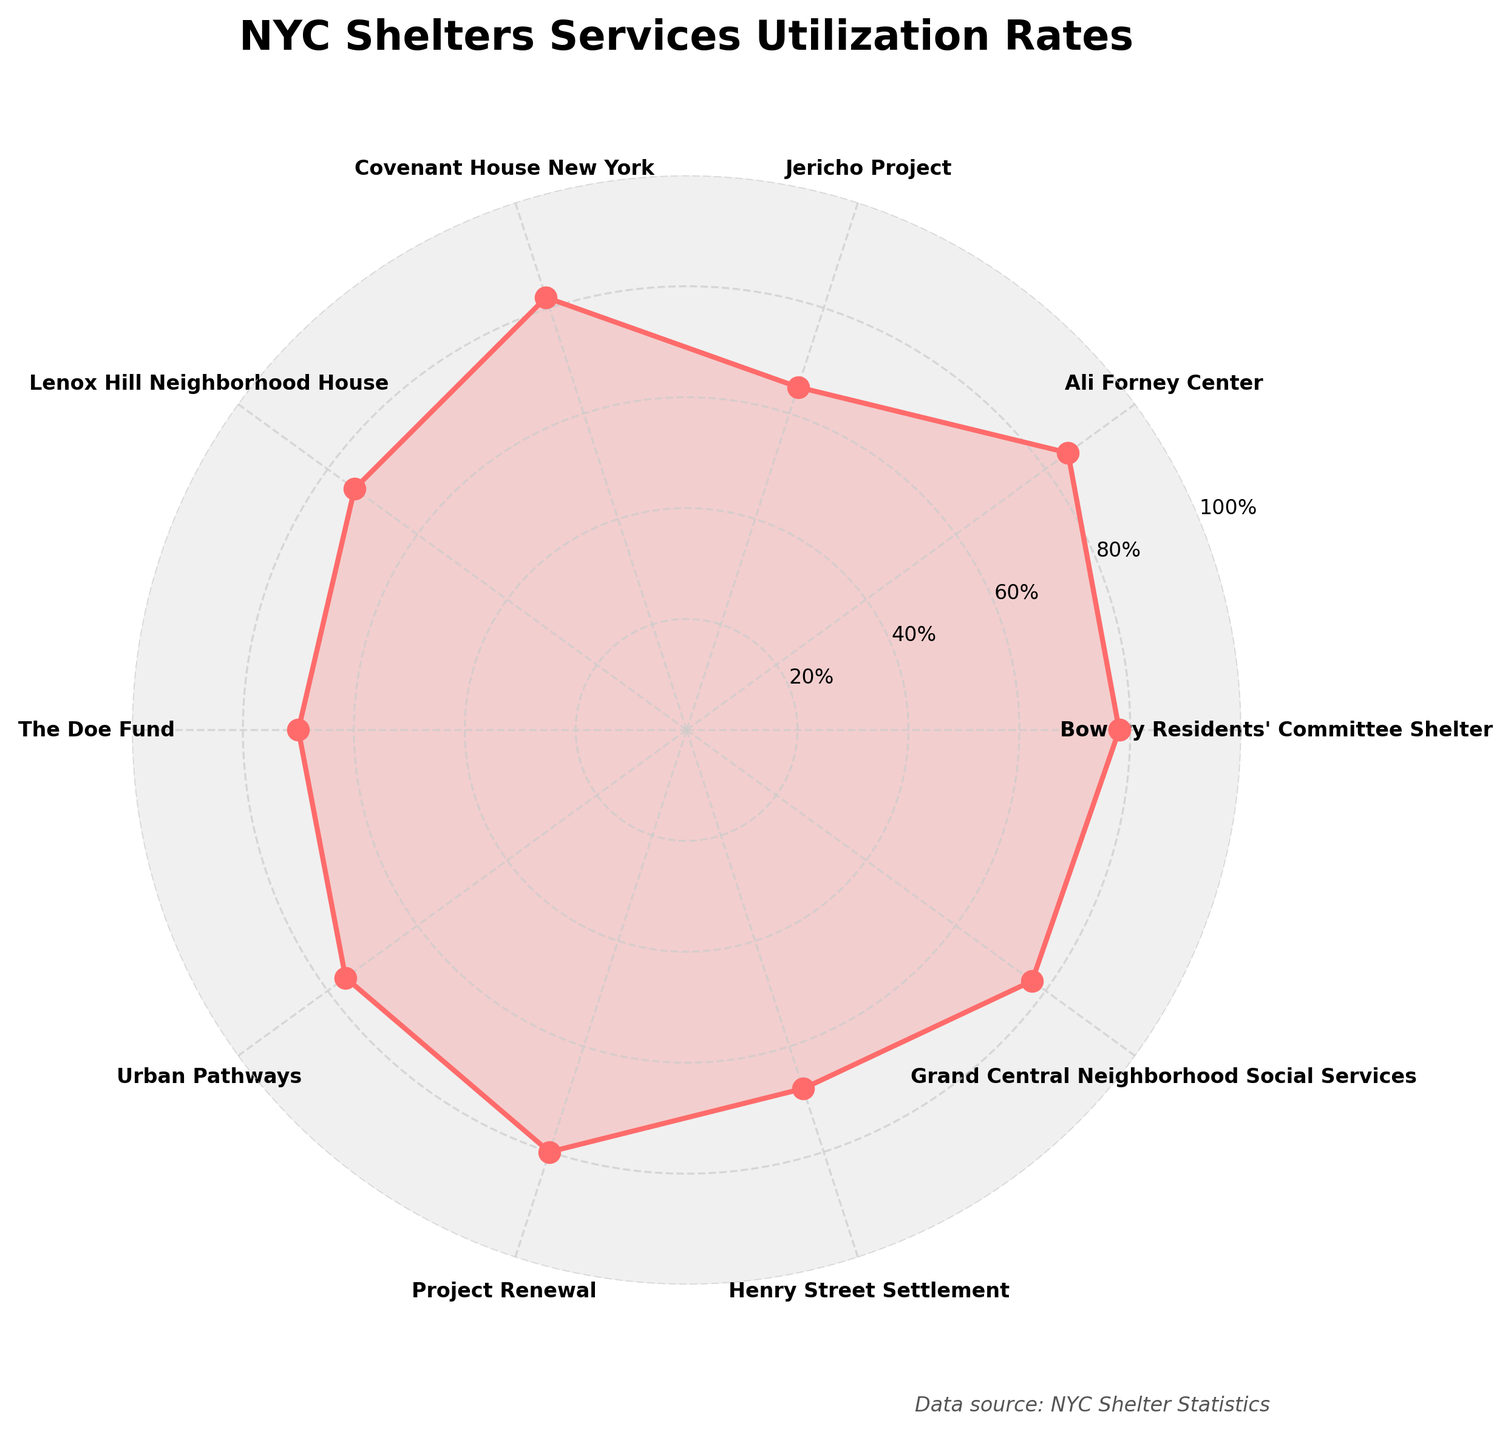What is the title of the chart? The title is displayed at the top of the chart and reads "NYC Shelters Services Utilization Rates".
Answer: NYC Shelters Services Utilization Rates How many shelters are represented in the chart? The number of shelters can be counted along the edges of the polar chart where the shelter names are listed.
Answer: 10 Which shelter has the highest services utilization rate? The highest utilization rate can be identified by locating the peak point furthest from the center of the chart. This corresponds to the Ali Forney Center with a rate of 85%.
Answer: Ali Forney Center How many shelters have a services utilization rate above 75%? Identify and count all shelters with data points positioned at or above the 75% mark on the radial scale. These shelters are the Bowery Residents' Committee Shelter, Ali Forney Center, Covenant House New York, Urban Pathways, Project Renewal, and Grand Central Neighborhood Social Services.
Answer: 6 What location are all the shelters in? Refer to the chart's labels, which consistently indicate that each shelter is in Manhattan. There are no other locations mentioned.
Answer: Manhattan What is the median services utilization rate of the shelters? Arrange the services utilization rates in ascending order and find the median. The sorted rates are 65, 68, 70, 74, 76, 77, 78, 80, 82, 85. The median is the average of the two middle values, 76 and 77, resulting in (76 + 77) / 2 = 76.5%.
Answer: 76.5% Which shelter has a lower services utilization rate: The Doe Fund or Jericho Project? Compare the data points on the plot for The Doe Fund (70%) and Jericho Project (65%), where Jericho Project has a lower rate.
Answer: Jericho Project What is the average services utilization rate of the top three shelters? Identify the top three shelters (Ali Forney Center, Covenant House New York, and Project Renewal) and calculate their average rate. The rates are 85, 82, and 80. Adding these gives a total of 247, and dividing by 3 provides an average of 247 / 3 = 82.3%.
Answer: 82.3% Which shelter has a utilization rate closest to the overall average? First, calculate the overall average of all shelters: (78+85+65+82+74+70+76+80+68+77) / 10 = 75.5%. The shelter closest to this average rate is Lenox Hill Neighborhood House with a rate of 74%.
Answer: Lenox Hill Neighborhood House What shape does the data form on the polar chart? The structure formed by plotting the utilization rates on the polar chart is a closed, irregular polygon filled with a red hue.
Answer: Irregular polygon 